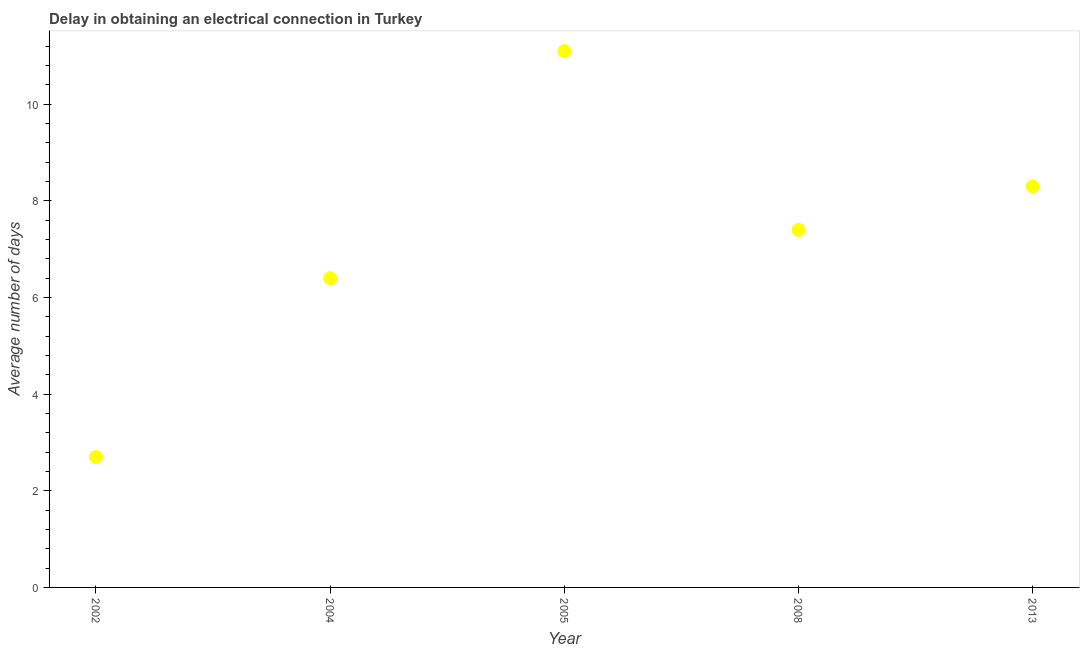What is the dalay in electrical connection in 2005?
Your answer should be compact. 11.1. In which year was the dalay in electrical connection minimum?
Give a very brief answer. 2002. What is the sum of the dalay in electrical connection?
Make the answer very short. 35.9. What is the average dalay in electrical connection per year?
Ensure brevity in your answer.  7.18. What is the median dalay in electrical connection?
Provide a succinct answer. 7.4. Do a majority of the years between 2013 and 2002 (inclusive) have dalay in electrical connection greater than 5.2 days?
Keep it short and to the point. Yes. What is the ratio of the dalay in electrical connection in 2002 to that in 2013?
Your response must be concise. 0.33. Is the dalay in electrical connection in 2004 less than that in 2008?
Give a very brief answer. Yes. What is the difference between the highest and the second highest dalay in electrical connection?
Your response must be concise. 2.8. Is the sum of the dalay in electrical connection in 2005 and 2013 greater than the maximum dalay in electrical connection across all years?
Ensure brevity in your answer.  Yes. What is the difference between the highest and the lowest dalay in electrical connection?
Your answer should be compact. 8.4. Does the dalay in electrical connection monotonically increase over the years?
Offer a terse response. No. Does the graph contain grids?
Give a very brief answer. No. What is the title of the graph?
Offer a very short reply. Delay in obtaining an electrical connection in Turkey. What is the label or title of the X-axis?
Your answer should be compact. Year. What is the label or title of the Y-axis?
Provide a short and direct response. Average number of days. What is the Average number of days in 2002?
Make the answer very short. 2.7. What is the Average number of days in 2004?
Your answer should be compact. 6.4. What is the Average number of days in 2008?
Provide a short and direct response. 7.4. What is the Average number of days in 2013?
Ensure brevity in your answer.  8.3. What is the difference between the Average number of days in 2002 and 2008?
Offer a terse response. -4.7. What is the difference between the Average number of days in 2004 and 2005?
Offer a terse response. -4.7. What is the difference between the Average number of days in 2004 and 2008?
Your answer should be very brief. -1. What is the ratio of the Average number of days in 2002 to that in 2004?
Make the answer very short. 0.42. What is the ratio of the Average number of days in 2002 to that in 2005?
Provide a succinct answer. 0.24. What is the ratio of the Average number of days in 2002 to that in 2008?
Give a very brief answer. 0.36. What is the ratio of the Average number of days in 2002 to that in 2013?
Give a very brief answer. 0.33. What is the ratio of the Average number of days in 2004 to that in 2005?
Give a very brief answer. 0.58. What is the ratio of the Average number of days in 2004 to that in 2008?
Ensure brevity in your answer.  0.86. What is the ratio of the Average number of days in 2004 to that in 2013?
Your response must be concise. 0.77. What is the ratio of the Average number of days in 2005 to that in 2013?
Ensure brevity in your answer.  1.34. What is the ratio of the Average number of days in 2008 to that in 2013?
Your response must be concise. 0.89. 